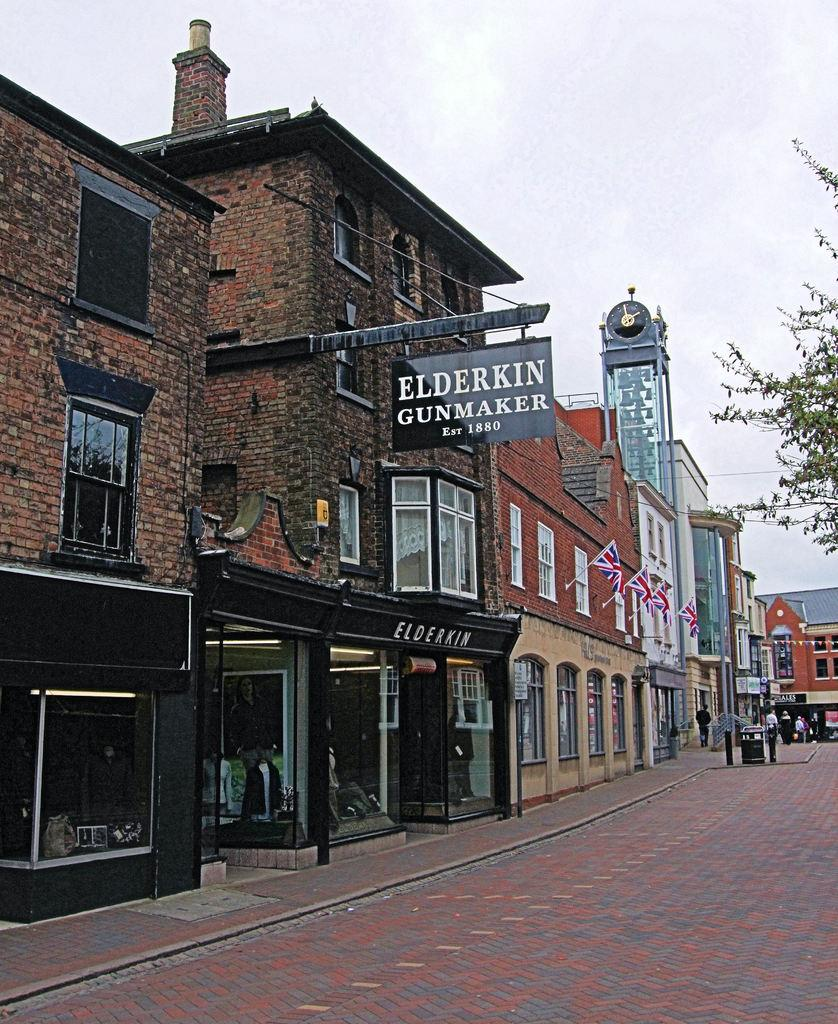What type of structures can be seen in the image? There are buildings in the image. Can you describe any specific features of the buildings? There is a name board hanging on a pole of a building. What else is visible in the image besides the buildings? There are flags, people, a tree, and a cloudy sky visible in the image. How many uncles are standing near the coast in the image? There is no mention of uncles or a coast in the image. 